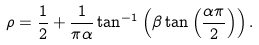<formula> <loc_0><loc_0><loc_500><loc_500>\rho = \frac { 1 } { 2 } + \frac { 1 } { \pi \alpha } \tan ^ { - 1 } \left ( \beta \tan \left ( \frac { \alpha \pi } { 2 } \right ) \right ) .</formula> 